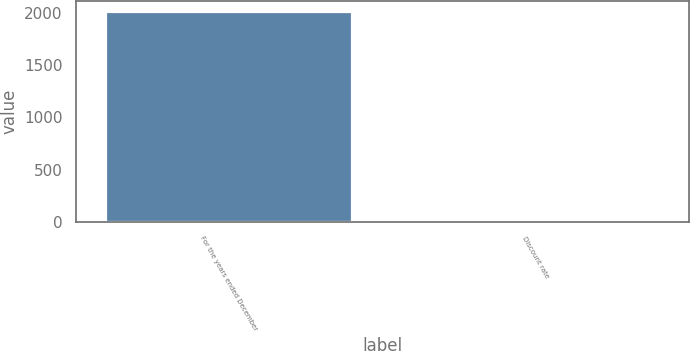Convert chart to OTSL. <chart><loc_0><loc_0><loc_500><loc_500><bar_chart><fcel>For the years ended December<fcel>Discount rate<nl><fcel>2009<fcel>6.4<nl></chart> 